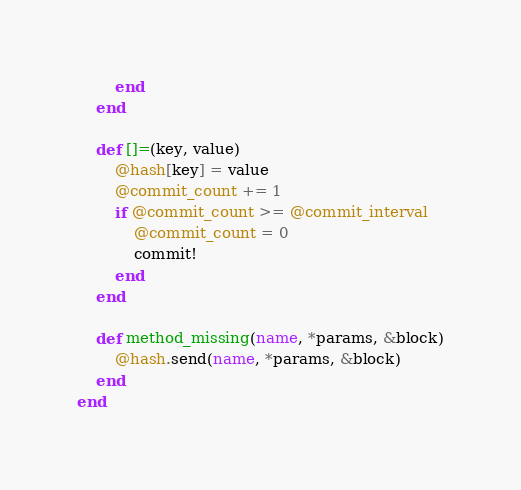<code> <loc_0><loc_0><loc_500><loc_500><_Ruby_>		end
	end

	def []=(key, value)
		@hash[key] = value
		@commit_count += 1
		if @commit_count >= @commit_interval
			@commit_count = 0
			commit!
		end
	end

	def method_missing(name, *params, &block)
		@hash.send(name, *params, &block)
	end
end
</code> 